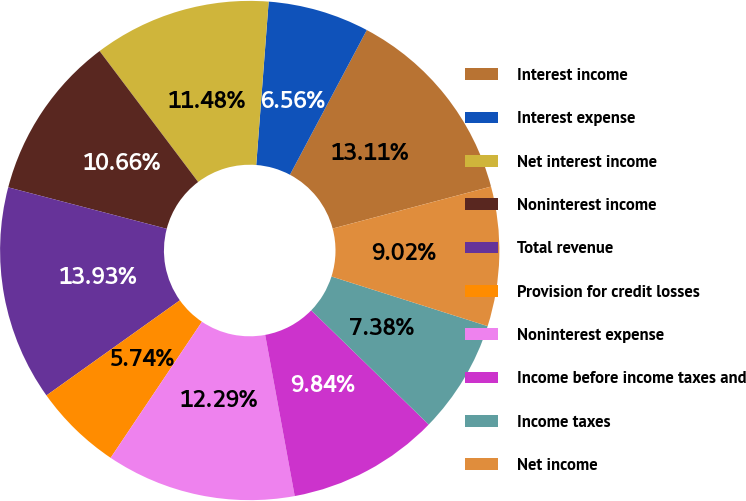Convert chart to OTSL. <chart><loc_0><loc_0><loc_500><loc_500><pie_chart><fcel>Interest income<fcel>Interest expense<fcel>Net interest income<fcel>Noninterest income<fcel>Total revenue<fcel>Provision for credit losses<fcel>Noninterest expense<fcel>Income before income taxes and<fcel>Income taxes<fcel>Net income<nl><fcel>13.11%<fcel>6.56%<fcel>11.48%<fcel>10.66%<fcel>13.93%<fcel>5.74%<fcel>12.29%<fcel>9.84%<fcel>7.38%<fcel>9.02%<nl></chart> 